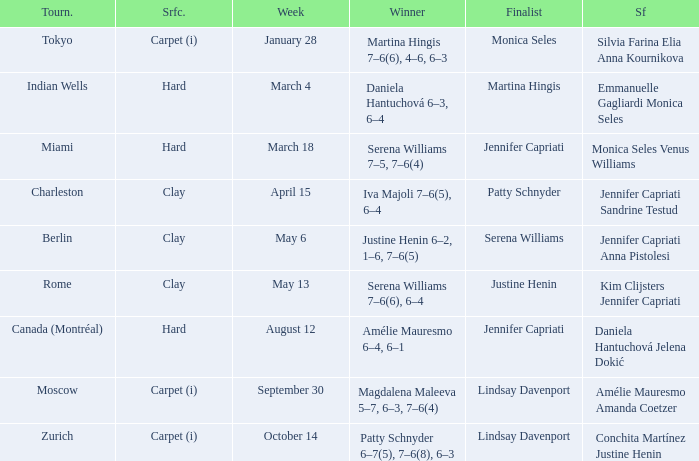Could you help me parse every detail presented in this table? {'header': ['Tourn.', 'Srfc.', 'Week', 'Winner', 'Finalist', 'Sf'], 'rows': [['Tokyo', 'Carpet (i)', 'January 28', 'Martina Hingis 7–6(6), 4–6, 6–3', 'Monica Seles', 'Silvia Farina Elia Anna Kournikova'], ['Indian Wells', 'Hard', 'March 4', 'Daniela Hantuchová 6–3, 6–4', 'Martina Hingis', 'Emmanuelle Gagliardi Monica Seles'], ['Miami', 'Hard', 'March 18', 'Serena Williams 7–5, 7–6(4)', 'Jennifer Capriati', 'Monica Seles Venus Williams'], ['Charleston', 'Clay', 'April 15', 'Iva Majoli 7–6(5), 6–4', 'Patty Schnyder', 'Jennifer Capriati Sandrine Testud'], ['Berlin', 'Clay', 'May 6', 'Justine Henin 6–2, 1–6, 7–6(5)', 'Serena Williams', 'Jennifer Capriati Anna Pistolesi'], ['Rome', 'Clay', 'May 13', 'Serena Williams 7–6(6), 6–4', 'Justine Henin', 'Kim Clijsters Jennifer Capriati'], ['Canada (Montréal)', 'Hard', 'August 12', 'Amélie Mauresmo 6–4, 6–1', 'Jennifer Capriati', 'Daniela Hantuchová Jelena Dokić'], ['Moscow', 'Carpet (i)', 'September 30', 'Magdalena Maleeva 5–7, 6–3, 7–6(4)', 'Lindsay Davenport', 'Amélie Mauresmo Amanda Coetzer'], ['Zurich', 'Carpet (i)', 'October 14', 'Patty Schnyder 6–7(5), 7–6(8), 6–3', 'Lindsay Davenport', 'Conchita Martínez Justine Henin']]} What week was the finalist Martina Hingis? March 4. 